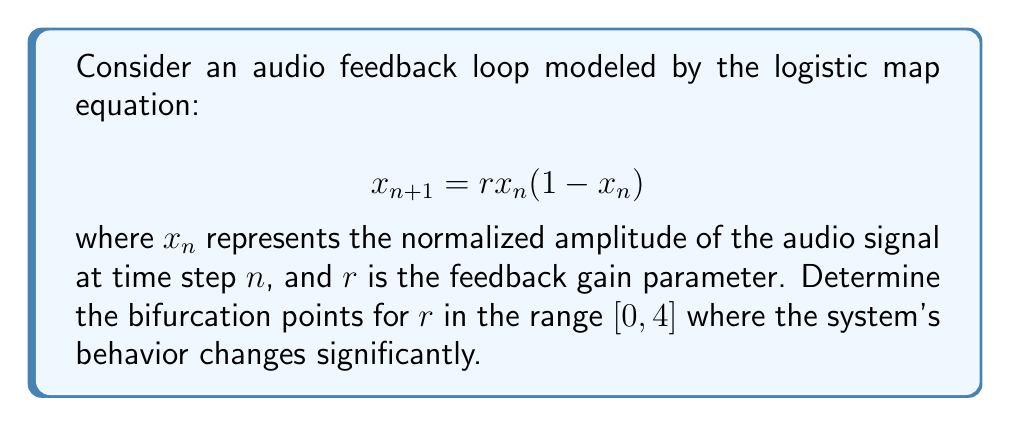What is the answer to this math problem? To find the bifurcation points, we need to analyze the stability of the fixed points and period-doubling bifurcations:

1. Find the fixed points:
   Set $x_{n+1} = x_n = x^*$
   $$x^* = rx^*(1-x^*)$$
   Solving this equation gives two fixed points:
   $x^* = 0$ and $x^* = 1 - \frac{1}{r}$

2. Analyze stability of fixed points:
   Calculate the derivative of the map: $f'(x) = r(1-2x)$
   For $x^* = 0$: $|f'(0)| = |r| < 1$ when $0 < r < 1$
   For $x^* = 1 - \frac{1}{r}$: $|f'(1-\frac{1}{r})| = |2-r| < 1$ when $1 < r < 3$

3. Identify period-doubling bifurcations:
   The first period-doubling occurs at $r = 3$
   Subsequent period-doubling bifurcations occur at:
   $r \approx 3.449$ (period-4)
   $r \approx 3.544$ (period-8)
   $r \approx 3.564$ (period-16)
   ...
   The accumulation point of period-doubling is at $r \approx 3.57$

4. Chaos onset:
   For $r > 3.57$, the system exhibits chaotic behavior with periodic windows

Therefore, the main bifurcation points are:
- $r = 1$: Transcritical bifurcation (exchange of stability between fixed points)
- $r = 3$: First period-doubling bifurcation
- $r \approx 3.57$: Onset of chaos (accumulation point of period-doubling)
Answer: $r = 1$, $r = 3$, $r \approx 3.57$ 